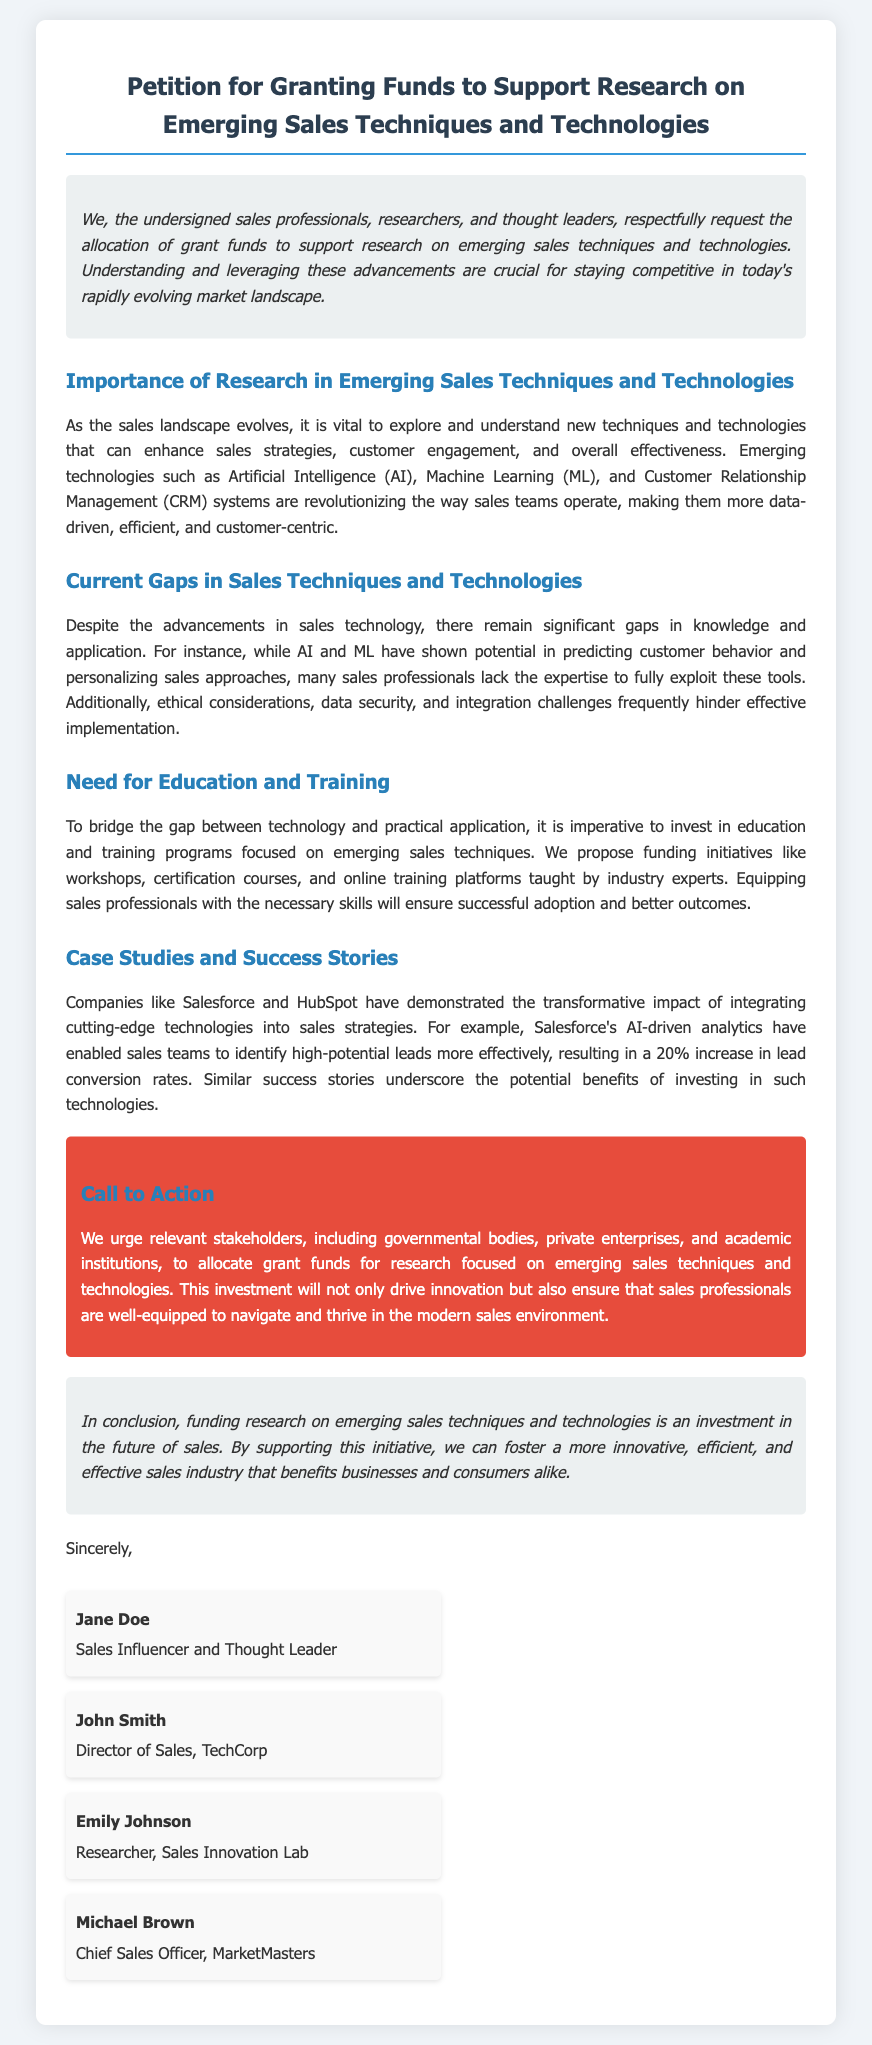What is the title of the petition? The title is prominently displayed at the top of the document.
Answer: Petition for Granting Funds to Support Research on Emerging Sales Techniques and Technologies Who is the Chief Sales Officer mentioned in the document? Michael Brown is identified as the Chief Sales Officer in the signatories section.
Answer: Michael Brown What key technologies are mentioned as transforming sales strategies? The document highlights important technologies that are reshaping the sales landscape.
Answer: Artificial Intelligence, Machine Learning, Customer Relationship Management What percentage increase in lead conversion rates did Salesforce achieve? The document provides a concrete example of success attributed to technology integration.
Answer: 20% What are the proposed initiatives for education and training? The document suggests initiatives aimed at improving sales professionals' skills.
Answer: workshops, certification courses, online training platforms What is the main call to action for stakeholders? The document stresses an important request directed towards various stakeholders.
Answer: allocate grant funds What is the closing statement about funding research? The conclusion emphasizes the overarching benefit of the proposed funding.
Answer: investment in the future of sales How many signatories are listed in the document? The number of individuals who support the petition can be counted.
Answer: four 